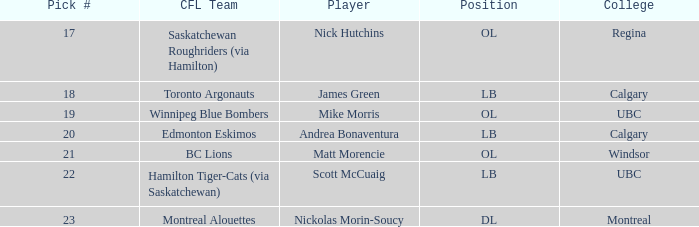What place is the player who traveled to regina in? OL. 